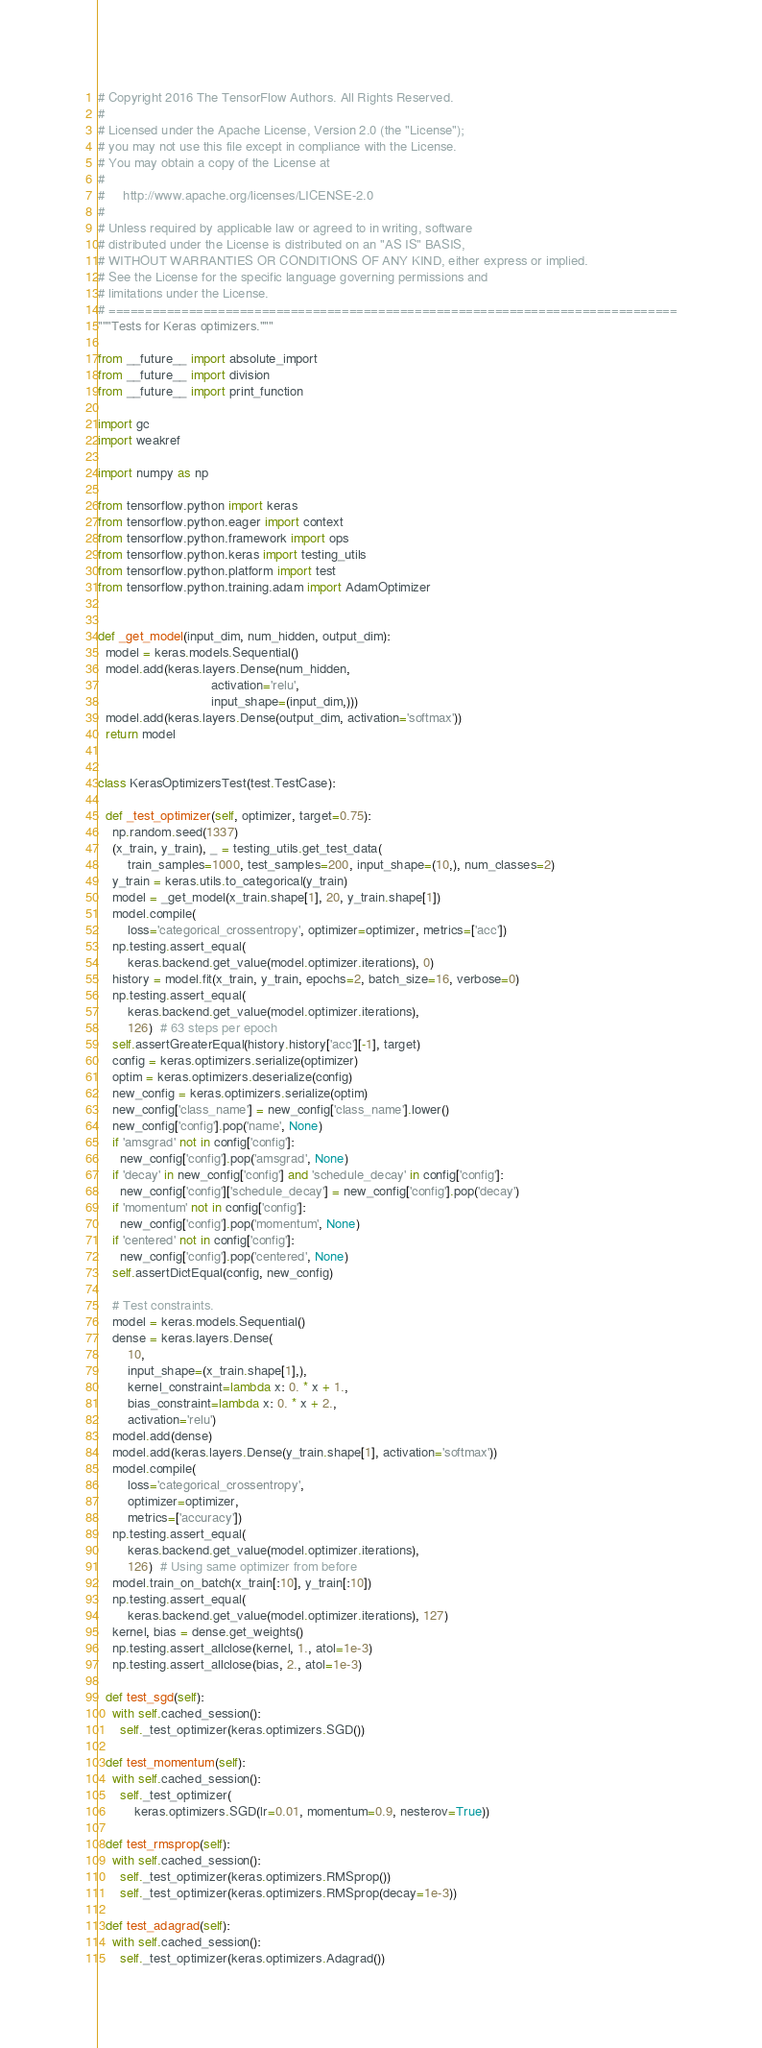<code> <loc_0><loc_0><loc_500><loc_500><_Python_># Copyright 2016 The TensorFlow Authors. All Rights Reserved.
#
# Licensed under the Apache License, Version 2.0 (the "License");
# you may not use this file except in compliance with the License.
# You may obtain a copy of the License at
#
#     http://www.apache.org/licenses/LICENSE-2.0
#
# Unless required by applicable law or agreed to in writing, software
# distributed under the License is distributed on an "AS IS" BASIS,
# WITHOUT WARRANTIES OR CONDITIONS OF ANY KIND, either express or implied.
# See the License for the specific language governing permissions and
# limitations under the License.
# ==============================================================================
"""Tests for Keras optimizers."""

from __future__ import absolute_import
from __future__ import division
from __future__ import print_function

import gc
import weakref

import numpy as np

from tensorflow.python import keras
from tensorflow.python.eager import context
from tensorflow.python.framework import ops
from tensorflow.python.keras import testing_utils
from tensorflow.python.platform import test
from tensorflow.python.training.adam import AdamOptimizer


def _get_model(input_dim, num_hidden, output_dim):
  model = keras.models.Sequential()
  model.add(keras.layers.Dense(num_hidden,
                               activation='relu',
                               input_shape=(input_dim,)))
  model.add(keras.layers.Dense(output_dim, activation='softmax'))
  return model


class KerasOptimizersTest(test.TestCase):

  def _test_optimizer(self, optimizer, target=0.75):
    np.random.seed(1337)
    (x_train, y_train), _ = testing_utils.get_test_data(
        train_samples=1000, test_samples=200, input_shape=(10,), num_classes=2)
    y_train = keras.utils.to_categorical(y_train)
    model = _get_model(x_train.shape[1], 20, y_train.shape[1])
    model.compile(
        loss='categorical_crossentropy', optimizer=optimizer, metrics=['acc'])
    np.testing.assert_equal(
        keras.backend.get_value(model.optimizer.iterations), 0)
    history = model.fit(x_train, y_train, epochs=2, batch_size=16, verbose=0)
    np.testing.assert_equal(
        keras.backend.get_value(model.optimizer.iterations),
        126)  # 63 steps per epoch
    self.assertGreaterEqual(history.history['acc'][-1], target)
    config = keras.optimizers.serialize(optimizer)
    optim = keras.optimizers.deserialize(config)
    new_config = keras.optimizers.serialize(optim)
    new_config['class_name'] = new_config['class_name'].lower()
    new_config['config'].pop('name', None)
    if 'amsgrad' not in config['config']:
      new_config['config'].pop('amsgrad', None)
    if 'decay' in new_config['config'] and 'schedule_decay' in config['config']:
      new_config['config']['schedule_decay'] = new_config['config'].pop('decay')
    if 'momentum' not in config['config']:
      new_config['config'].pop('momentum', None)
    if 'centered' not in config['config']:
      new_config['config'].pop('centered', None)
    self.assertDictEqual(config, new_config)

    # Test constraints.
    model = keras.models.Sequential()
    dense = keras.layers.Dense(
        10,
        input_shape=(x_train.shape[1],),
        kernel_constraint=lambda x: 0. * x + 1.,
        bias_constraint=lambda x: 0. * x + 2.,
        activation='relu')
    model.add(dense)
    model.add(keras.layers.Dense(y_train.shape[1], activation='softmax'))
    model.compile(
        loss='categorical_crossentropy',
        optimizer=optimizer,
        metrics=['accuracy'])
    np.testing.assert_equal(
        keras.backend.get_value(model.optimizer.iterations),
        126)  # Using same optimizer from before
    model.train_on_batch(x_train[:10], y_train[:10])
    np.testing.assert_equal(
        keras.backend.get_value(model.optimizer.iterations), 127)
    kernel, bias = dense.get_weights()
    np.testing.assert_allclose(kernel, 1., atol=1e-3)
    np.testing.assert_allclose(bias, 2., atol=1e-3)

  def test_sgd(self):
    with self.cached_session():
      self._test_optimizer(keras.optimizers.SGD())

  def test_momentum(self):
    with self.cached_session():
      self._test_optimizer(
          keras.optimizers.SGD(lr=0.01, momentum=0.9, nesterov=True))

  def test_rmsprop(self):
    with self.cached_session():
      self._test_optimizer(keras.optimizers.RMSprop())
      self._test_optimizer(keras.optimizers.RMSprop(decay=1e-3))

  def test_adagrad(self):
    with self.cached_session():
      self._test_optimizer(keras.optimizers.Adagrad())</code> 